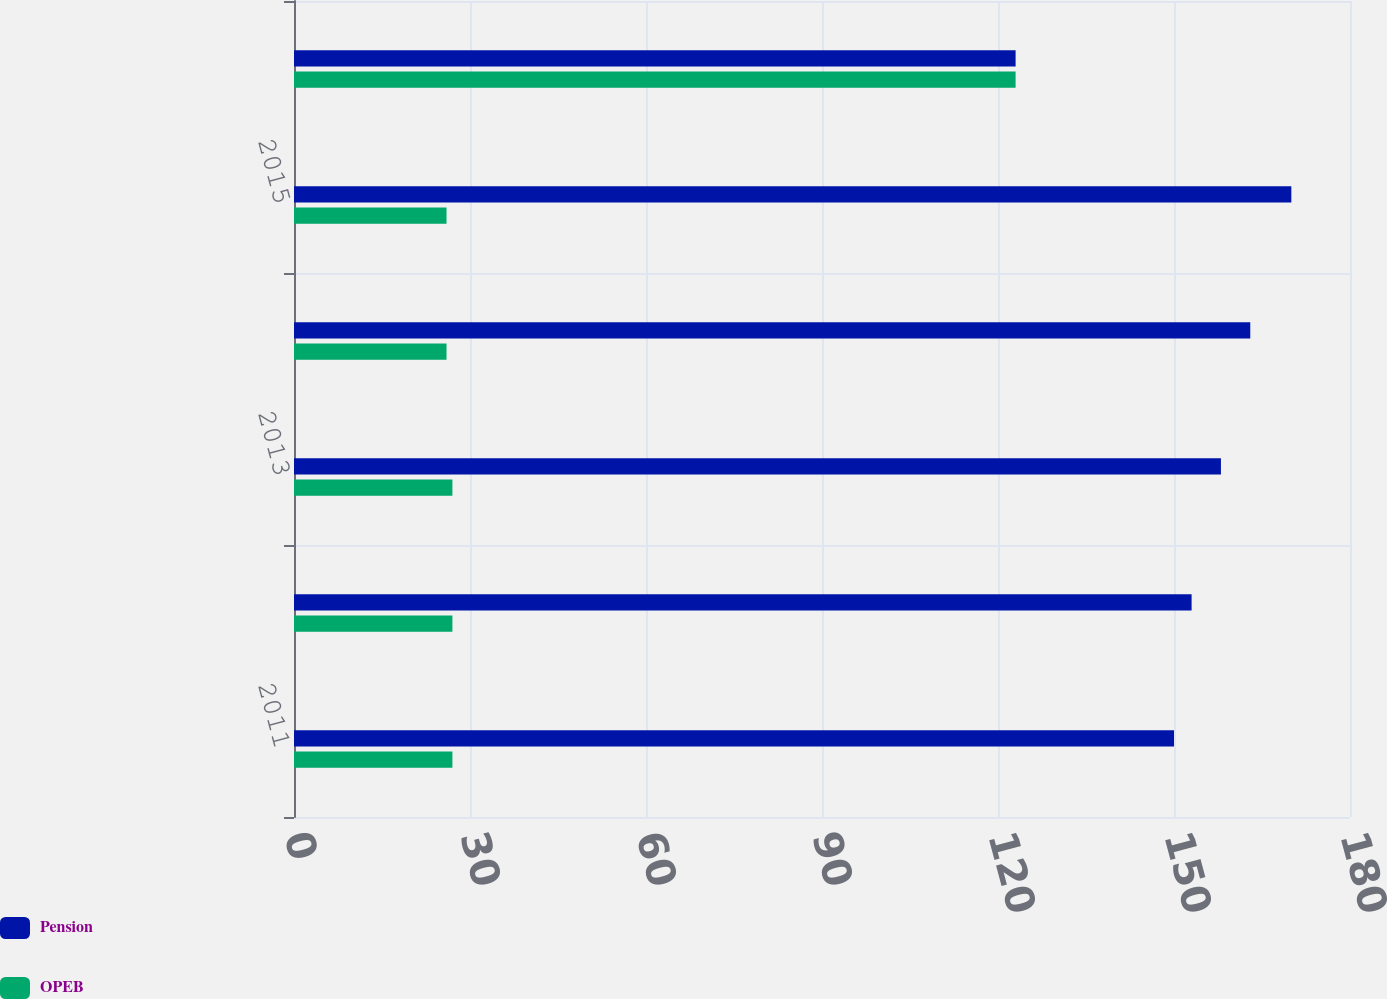Convert chart. <chart><loc_0><loc_0><loc_500><loc_500><stacked_bar_chart><ecel><fcel>2011<fcel>2012<fcel>2013<fcel>2014<fcel>2015<fcel>Years 2016 -2020<nl><fcel>Pension<fcel>150<fcel>153<fcel>158<fcel>163<fcel>170<fcel>123<nl><fcel>OPEB<fcel>27<fcel>27<fcel>27<fcel>26<fcel>26<fcel>123<nl></chart> 